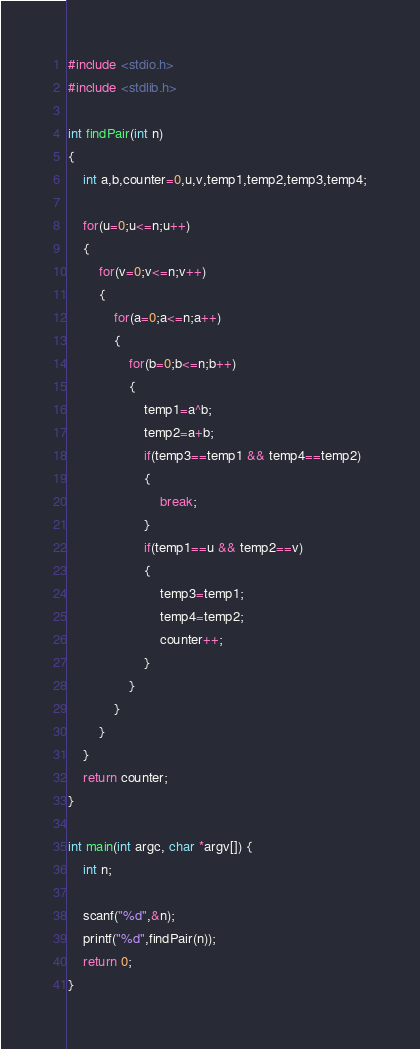Convert code to text. <code><loc_0><loc_0><loc_500><loc_500><_C_>#include <stdio.h>
#include <stdlib.h>

int findPair(int n)
{
	int a,b,counter=0,u,v,temp1,temp2,temp3,temp4;

	for(u=0;u<=n;u++)
	{
		for(v=0;v<=n;v++)
		{
			for(a=0;a<=n;a++)
			{
				for(b=0;b<=n;b++)
				{
					temp1=a^b;
					temp2=a+b;
					if(temp3==temp1 && temp4==temp2)
					{
						break;
					}
					if(temp1==u && temp2==v)
					{
						temp3=temp1;
						temp4=temp2;
						counter++;
					}
				}
			}
		}
	}
	return counter;
}

int main(int argc, char *argv[]) {
	int n;

	scanf("%d",&n);
	printf("%d",findPair(n));
	return 0;
}</code> 